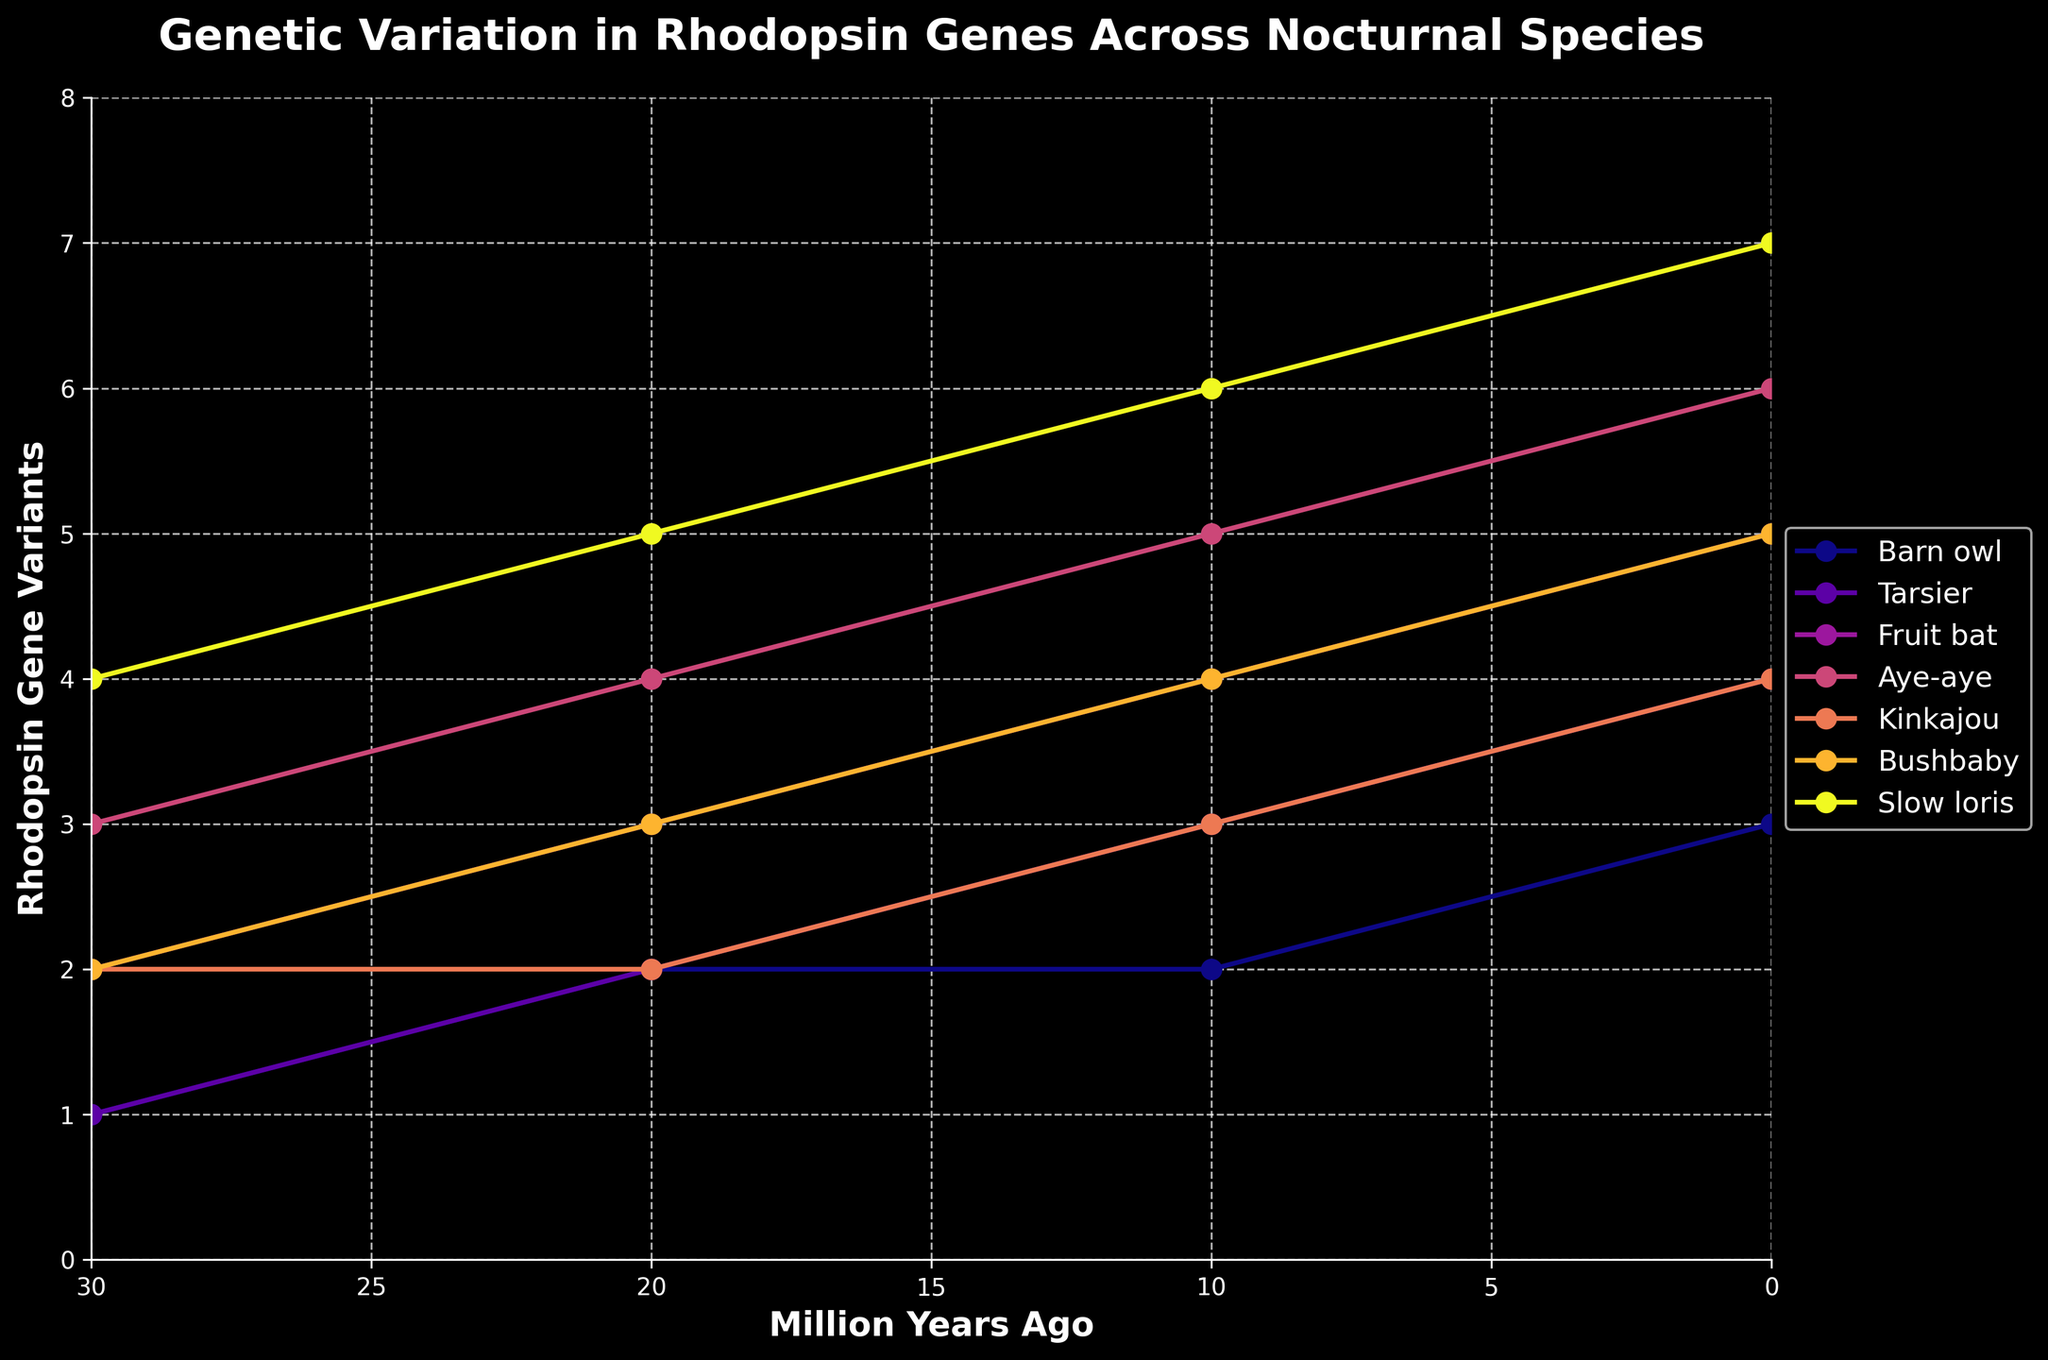How many rhodopsin gene variants did the Aye-aye lose over the past 20 million years? The initial number of rhodopsin gene variants for the Aye-aye 20 million years ago was 4. The current number is 6. The Aye-aye lost 6 - 4 = 2 variants.
Answer: 2 Which species showed the least variation in the number of rhodopsin gene variants over 30 million years? Examining the trend lines, the Barn owl showed the least variation, with a difference of only 2 variants (from 3 to 1) over 30 million years.
Answer: Barn owl What is the average number of rhodopsin gene variants for the Tarsier 10, 20, and 30 million years ago? Tarsier variants are: 10 MYA = 3, 20 MYA = 2, 30 MYA = 1. The mean is (3 + 2 + 1) / 3 = 2.
Answer: 2 Which species currently have the highest number of rhodopsin gene variants? Looking at the data points at present (0 million years ago), the Slow loris has the highest number with 7 variants.
Answer: Slow loris Among the species, which one has the steepest decline in rhodopsin gene variants from 30 to 0 million years ago? The Aye-aye shows the steepest decline, going from 6 to 3 variants, a reduction of 3 variants.
Answer: Aye-aye Compare the number of rhodopsin gene variants for the Bushbaby and Fruit bat 20 million years ago. Which has more, and by how much? The Bushbaby has 3 variants, and the Fruit bat has 3 variants. The difference is 0.
Answer: None, equal How has the rhodopsin gene variant count changed for the Kinkajou in the past 30 million years? The Kinkajou's gene variant count changed from 2 to 4. This means a change of 4 - 2 = 2 variants.
Answer: 2 Did any species experience an increase in rhodopsin gene variants over the past 30 million years? All species experienced a decline in rhodopsin gene variants over the 30 million years.
Answer: No What is the difference in the number of gene variants between the species with the most and the species with the least variants 10 million years ago? The Slow loris has the most variants at 10 MYA with 6, and the Barn owl has the least with 2. The difference is 6 - 2 = 4.
Answer: 4 